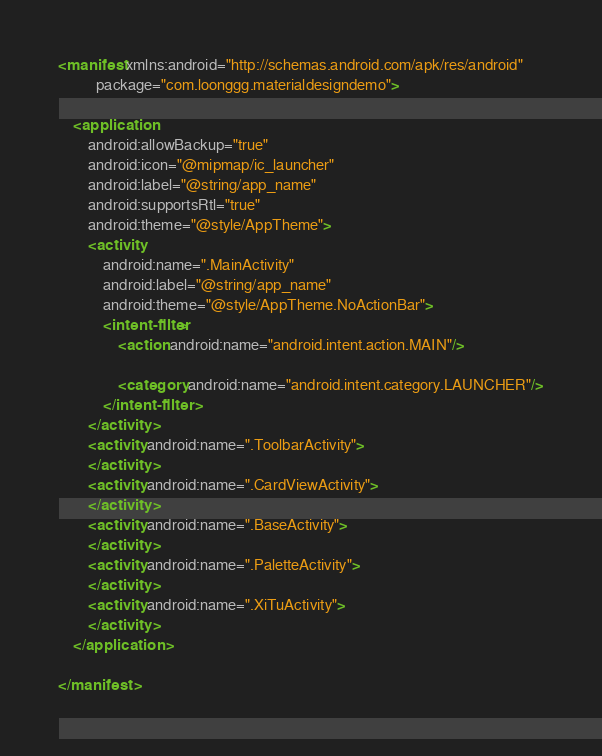<code> <loc_0><loc_0><loc_500><loc_500><_XML_><manifest xmlns:android="http://schemas.android.com/apk/res/android"
          package="com.loonggg.materialdesigndemo">

    <application
        android:allowBackup="true"
        android:icon="@mipmap/ic_launcher"
        android:label="@string/app_name"
        android:supportsRtl="true"
        android:theme="@style/AppTheme">
        <activity
            android:name=".MainActivity"
            android:label="@string/app_name"
            android:theme="@style/AppTheme.NoActionBar">
            <intent-filter>
                <action android:name="android.intent.action.MAIN"/>

                <category android:name="android.intent.category.LAUNCHER"/>
            </intent-filter>
        </activity>
        <activity android:name=".ToolbarActivity">
        </activity>
        <activity android:name=".CardViewActivity">
        </activity>
        <activity android:name=".BaseActivity">
        </activity>
        <activity android:name=".PaletteActivity">
        </activity>
        <activity android:name=".XiTuActivity">
        </activity>
    </application>

</manifest></code> 